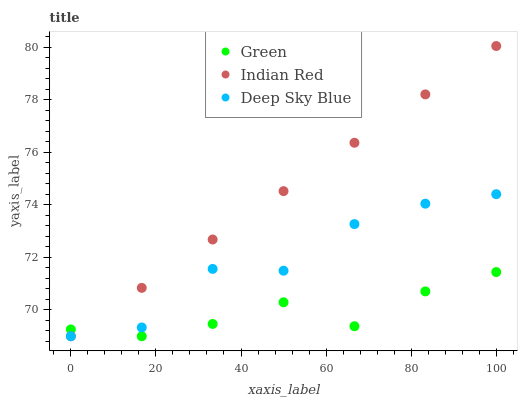Does Green have the minimum area under the curve?
Answer yes or no. Yes. Does Indian Red have the maximum area under the curve?
Answer yes or no. Yes. Does Deep Sky Blue have the minimum area under the curve?
Answer yes or no. No. Does Deep Sky Blue have the maximum area under the curve?
Answer yes or no. No. Is Indian Red the smoothest?
Answer yes or no. Yes. Is Deep Sky Blue the roughest?
Answer yes or no. Yes. Is Deep Sky Blue the smoothest?
Answer yes or no. No. Is Indian Red the roughest?
Answer yes or no. No. Does Green have the lowest value?
Answer yes or no. Yes. Does Indian Red have the highest value?
Answer yes or no. Yes. Does Deep Sky Blue have the highest value?
Answer yes or no. No. Does Deep Sky Blue intersect Green?
Answer yes or no. Yes. Is Deep Sky Blue less than Green?
Answer yes or no. No. Is Deep Sky Blue greater than Green?
Answer yes or no. No. 